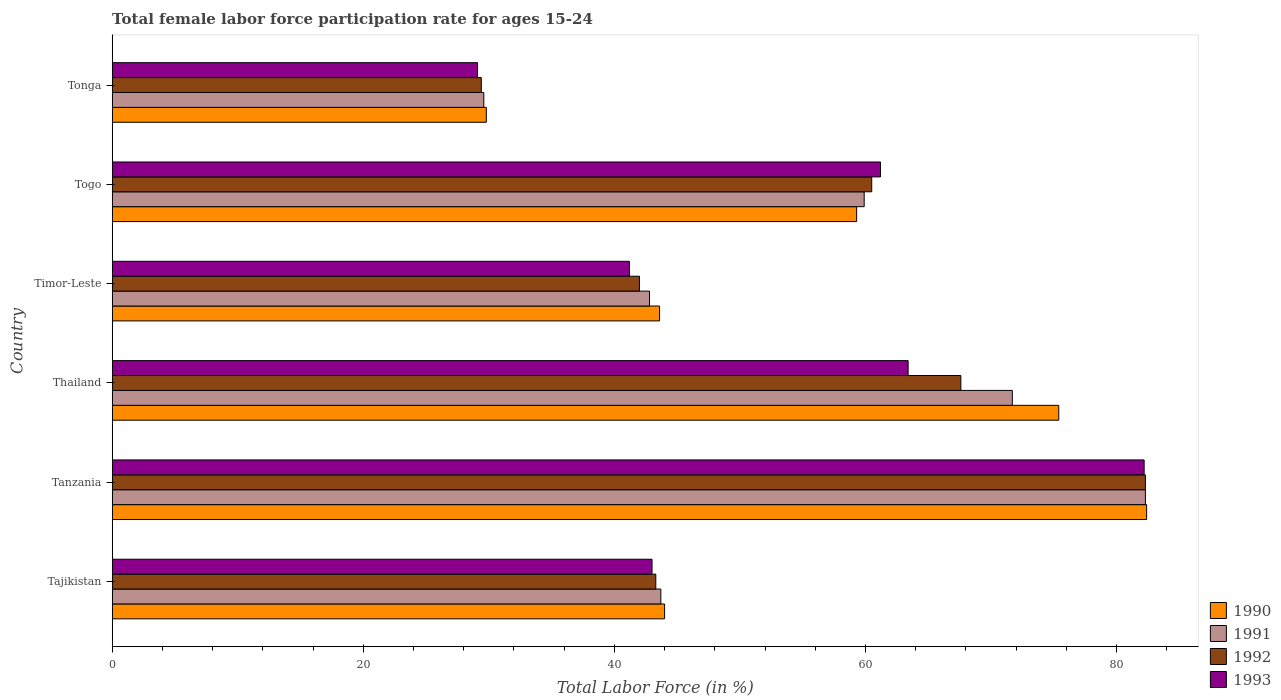How many different coloured bars are there?
Your answer should be compact. 4. How many groups of bars are there?
Provide a succinct answer. 6. Are the number of bars per tick equal to the number of legend labels?
Provide a succinct answer. Yes. Are the number of bars on each tick of the Y-axis equal?
Give a very brief answer. Yes. What is the label of the 3rd group of bars from the top?
Ensure brevity in your answer.  Timor-Leste. In how many cases, is the number of bars for a given country not equal to the number of legend labels?
Your response must be concise. 0. What is the female labor force participation rate in 1991 in Togo?
Give a very brief answer. 59.9. Across all countries, what is the maximum female labor force participation rate in 1991?
Your response must be concise. 82.3. Across all countries, what is the minimum female labor force participation rate in 1993?
Offer a terse response. 29.1. In which country was the female labor force participation rate in 1991 maximum?
Provide a succinct answer. Tanzania. In which country was the female labor force participation rate in 1990 minimum?
Your answer should be compact. Tonga. What is the total female labor force participation rate in 1993 in the graph?
Your answer should be very brief. 320.1. What is the difference between the female labor force participation rate in 1993 in Tajikistan and that in Timor-Leste?
Your answer should be compact. 1.8. What is the difference between the female labor force participation rate in 1990 in Togo and the female labor force participation rate in 1991 in Tanzania?
Your answer should be compact. -23. What is the average female labor force participation rate in 1991 per country?
Keep it short and to the point. 55. What is the difference between the female labor force participation rate in 1992 and female labor force participation rate in 1991 in Togo?
Your answer should be compact. 0.6. In how many countries, is the female labor force participation rate in 1991 greater than 36 %?
Give a very brief answer. 5. What is the ratio of the female labor force participation rate in 1991 in Tanzania to that in Timor-Leste?
Your answer should be very brief. 1.92. Is the difference between the female labor force participation rate in 1992 in Timor-Leste and Tonga greater than the difference between the female labor force participation rate in 1991 in Timor-Leste and Tonga?
Offer a very short reply. No. What is the difference between the highest and the second highest female labor force participation rate in 1991?
Your answer should be very brief. 10.6. What is the difference between the highest and the lowest female labor force participation rate in 1991?
Give a very brief answer. 52.7. What does the 3rd bar from the top in Timor-Leste represents?
Offer a terse response. 1991. Are all the bars in the graph horizontal?
Offer a very short reply. Yes. Are the values on the major ticks of X-axis written in scientific E-notation?
Give a very brief answer. No. Does the graph contain any zero values?
Give a very brief answer. No. What is the title of the graph?
Offer a very short reply. Total female labor force participation rate for ages 15-24. What is the Total Labor Force (in %) in 1991 in Tajikistan?
Provide a short and direct response. 43.7. What is the Total Labor Force (in %) in 1992 in Tajikistan?
Provide a short and direct response. 43.3. What is the Total Labor Force (in %) of 1990 in Tanzania?
Offer a very short reply. 82.4. What is the Total Labor Force (in %) in 1991 in Tanzania?
Make the answer very short. 82.3. What is the Total Labor Force (in %) in 1992 in Tanzania?
Provide a succinct answer. 82.3. What is the Total Labor Force (in %) of 1993 in Tanzania?
Ensure brevity in your answer.  82.2. What is the Total Labor Force (in %) of 1990 in Thailand?
Provide a short and direct response. 75.4. What is the Total Labor Force (in %) in 1991 in Thailand?
Provide a short and direct response. 71.7. What is the Total Labor Force (in %) of 1992 in Thailand?
Provide a succinct answer. 67.6. What is the Total Labor Force (in %) in 1993 in Thailand?
Provide a succinct answer. 63.4. What is the Total Labor Force (in %) of 1990 in Timor-Leste?
Make the answer very short. 43.6. What is the Total Labor Force (in %) of 1991 in Timor-Leste?
Provide a short and direct response. 42.8. What is the Total Labor Force (in %) of 1993 in Timor-Leste?
Ensure brevity in your answer.  41.2. What is the Total Labor Force (in %) of 1990 in Togo?
Provide a succinct answer. 59.3. What is the Total Labor Force (in %) of 1991 in Togo?
Your answer should be compact. 59.9. What is the Total Labor Force (in %) in 1992 in Togo?
Offer a very short reply. 60.5. What is the Total Labor Force (in %) in 1993 in Togo?
Your answer should be compact. 61.2. What is the Total Labor Force (in %) of 1990 in Tonga?
Give a very brief answer. 29.8. What is the Total Labor Force (in %) of 1991 in Tonga?
Give a very brief answer. 29.6. What is the Total Labor Force (in %) in 1992 in Tonga?
Offer a very short reply. 29.4. What is the Total Labor Force (in %) in 1993 in Tonga?
Your answer should be very brief. 29.1. Across all countries, what is the maximum Total Labor Force (in %) in 1990?
Give a very brief answer. 82.4. Across all countries, what is the maximum Total Labor Force (in %) of 1991?
Your answer should be very brief. 82.3. Across all countries, what is the maximum Total Labor Force (in %) of 1992?
Your answer should be compact. 82.3. Across all countries, what is the maximum Total Labor Force (in %) of 1993?
Make the answer very short. 82.2. Across all countries, what is the minimum Total Labor Force (in %) in 1990?
Your answer should be compact. 29.8. Across all countries, what is the minimum Total Labor Force (in %) in 1991?
Offer a very short reply. 29.6. Across all countries, what is the minimum Total Labor Force (in %) of 1992?
Your answer should be very brief. 29.4. Across all countries, what is the minimum Total Labor Force (in %) of 1993?
Your answer should be very brief. 29.1. What is the total Total Labor Force (in %) of 1990 in the graph?
Your answer should be very brief. 334.5. What is the total Total Labor Force (in %) of 1991 in the graph?
Provide a short and direct response. 330. What is the total Total Labor Force (in %) in 1992 in the graph?
Your answer should be compact. 325.1. What is the total Total Labor Force (in %) in 1993 in the graph?
Give a very brief answer. 320.1. What is the difference between the Total Labor Force (in %) in 1990 in Tajikistan and that in Tanzania?
Offer a very short reply. -38.4. What is the difference between the Total Labor Force (in %) of 1991 in Tajikistan and that in Tanzania?
Your response must be concise. -38.6. What is the difference between the Total Labor Force (in %) of 1992 in Tajikistan and that in Tanzania?
Give a very brief answer. -39. What is the difference between the Total Labor Force (in %) of 1993 in Tajikistan and that in Tanzania?
Your response must be concise. -39.2. What is the difference between the Total Labor Force (in %) of 1990 in Tajikistan and that in Thailand?
Your response must be concise. -31.4. What is the difference between the Total Labor Force (in %) in 1992 in Tajikistan and that in Thailand?
Give a very brief answer. -24.3. What is the difference between the Total Labor Force (in %) in 1993 in Tajikistan and that in Thailand?
Your answer should be very brief. -20.4. What is the difference between the Total Labor Force (in %) of 1990 in Tajikistan and that in Timor-Leste?
Ensure brevity in your answer.  0.4. What is the difference between the Total Labor Force (in %) in 1991 in Tajikistan and that in Timor-Leste?
Offer a very short reply. 0.9. What is the difference between the Total Labor Force (in %) of 1992 in Tajikistan and that in Timor-Leste?
Provide a short and direct response. 1.3. What is the difference between the Total Labor Force (in %) of 1993 in Tajikistan and that in Timor-Leste?
Your answer should be very brief. 1.8. What is the difference between the Total Labor Force (in %) in 1990 in Tajikistan and that in Togo?
Your response must be concise. -15.3. What is the difference between the Total Labor Force (in %) in 1991 in Tajikistan and that in Togo?
Your answer should be compact. -16.2. What is the difference between the Total Labor Force (in %) in 1992 in Tajikistan and that in Togo?
Your answer should be very brief. -17.2. What is the difference between the Total Labor Force (in %) in 1993 in Tajikistan and that in Togo?
Offer a very short reply. -18.2. What is the difference between the Total Labor Force (in %) of 1990 in Tajikistan and that in Tonga?
Offer a very short reply. 14.2. What is the difference between the Total Labor Force (in %) in 1991 in Tajikistan and that in Tonga?
Give a very brief answer. 14.1. What is the difference between the Total Labor Force (in %) of 1993 in Tajikistan and that in Tonga?
Give a very brief answer. 13.9. What is the difference between the Total Labor Force (in %) in 1991 in Tanzania and that in Thailand?
Offer a terse response. 10.6. What is the difference between the Total Labor Force (in %) in 1992 in Tanzania and that in Thailand?
Give a very brief answer. 14.7. What is the difference between the Total Labor Force (in %) in 1990 in Tanzania and that in Timor-Leste?
Ensure brevity in your answer.  38.8. What is the difference between the Total Labor Force (in %) of 1991 in Tanzania and that in Timor-Leste?
Ensure brevity in your answer.  39.5. What is the difference between the Total Labor Force (in %) in 1992 in Tanzania and that in Timor-Leste?
Your answer should be compact. 40.3. What is the difference between the Total Labor Force (in %) in 1993 in Tanzania and that in Timor-Leste?
Give a very brief answer. 41. What is the difference between the Total Labor Force (in %) in 1990 in Tanzania and that in Togo?
Give a very brief answer. 23.1. What is the difference between the Total Labor Force (in %) of 1991 in Tanzania and that in Togo?
Ensure brevity in your answer.  22.4. What is the difference between the Total Labor Force (in %) of 1992 in Tanzania and that in Togo?
Provide a short and direct response. 21.8. What is the difference between the Total Labor Force (in %) of 1990 in Tanzania and that in Tonga?
Provide a short and direct response. 52.6. What is the difference between the Total Labor Force (in %) of 1991 in Tanzania and that in Tonga?
Your response must be concise. 52.7. What is the difference between the Total Labor Force (in %) in 1992 in Tanzania and that in Tonga?
Give a very brief answer. 52.9. What is the difference between the Total Labor Force (in %) in 1993 in Tanzania and that in Tonga?
Your answer should be compact. 53.1. What is the difference between the Total Labor Force (in %) of 1990 in Thailand and that in Timor-Leste?
Offer a terse response. 31.8. What is the difference between the Total Labor Force (in %) in 1991 in Thailand and that in Timor-Leste?
Provide a succinct answer. 28.9. What is the difference between the Total Labor Force (in %) of 1992 in Thailand and that in Timor-Leste?
Provide a succinct answer. 25.6. What is the difference between the Total Labor Force (in %) of 1990 in Thailand and that in Togo?
Provide a short and direct response. 16.1. What is the difference between the Total Labor Force (in %) of 1992 in Thailand and that in Togo?
Offer a very short reply. 7.1. What is the difference between the Total Labor Force (in %) in 1993 in Thailand and that in Togo?
Keep it short and to the point. 2.2. What is the difference between the Total Labor Force (in %) in 1990 in Thailand and that in Tonga?
Offer a terse response. 45.6. What is the difference between the Total Labor Force (in %) in 1991 in Thailand and that in Tonga?
Your answer should be compact. 42.1. What is the difference between the Total Labor Force (in %) in 1992 in Thailand and that in Tonga?
Give a very brief answer. 38.2. What is the difference between the Total Labor Force (in %) in 1993 in Thailand and that in Tonga?
Keep it short and to the point. 34.3. What is the difference between the Total Labor Force (in %) of 1990 in Timor-Leste and that in Togo?
Offer a very short reply. -15.7. What is the difference between the Total Labor Force (in %) in 1991 in Timor-Leste and that in Togo?
Your answer should be very brief. -17.1. What is the difference between the Total Labor Force (in %) in 1992 in Timor-Leste and that in Togo?
Your answer should be very brief. -18.5. What is the difference between the Total Labor Force (in %) of 1990 in Timor-Leste and that in Tonga?
Offer a very short reply. 13.8. What is the difference between the Total Labor Force (in %) of 1991 in Timor-Leste and that in Tonga?
Your answer should be very brief. 13.2. What is the difference between the Total Labor Force (in %) of 1992 in Timor-Leste and that in Tonga?
Give a very brief answer. 12.6. What is the difference between the Total Labor Force (in %) of 1993 in Timor-Leste and that in Tonga?
Offer a terse response. 12.1. What is the difference between the Total Labor Force (in %) of 1990 in Togo and that in Tonga?
Your response must be concise. 29.5. What is the difference between the Total Labor Force (in %) in 1991 in Togo and that in Tonga?
Your answer should be compact. 30.3. What is the difference between the Total Labor Force (in %) of 1992 in Togo and that in Tonga?
Provide a succinct answer. 31.1. What is the difference between the Total Labor Force (in %) in 1993 in Togo and that in Tonga?
Give a very brief answer. 32.1. What is the difference between the Total Labor Force (in %) of 1990 in Tajikistan and the Total Labor Force (in %) of 1991 in Tanzania?
Your response must be concise. -38.3. What is the difference between the Total Labor Force (in %) of 1990 in Tajikistan and the Total Labor Force (in %) of 1992 in Tanzania?
Provide a succinct answer. -38.3. What is the difference between the Total Labor Force (in %) in 1990 in Tajikistan and the Total Labor Force (in %) in 1993 in Tanzania?
Offer a very short reply. -38.2. What is the difference between the Total Labor Force (in %) of 1991 in Tajikistan and the Total Labor Force (in %) of 1992 in Tanzania?
Your answer should be very brief. -38.6. What is the difference between the Total Labor Force (in %) in 1991 in Tajikistan and the Total Labor Force (in %) in 1993 in Tanzania?
Offer a terse response. -38.5. What is the difference between the Total Labor Force (in %) in 1992 in Tajikistan and the Total Labor Force (in %) in 1993 in Tanzania?
Give a very brief answer. -38.9. What is the difference between the Total Labor Force (in %) in 1990 in Tajikistan and the Total Labor Force (in %) in 1991 in Thailand?
Offer a terse response. -27.7. What is the difference between the Total Labor Force (in %) of 1990 in Tajikistan and the Total Labor Force (in %) of 1992 in Thailand?
Ensure brevity in your answer.  -23.6. What is the difference between the Total Labor Force (in %) in 1990 in Tajikistan and the Total Labor Force (in %) in 1993 in Thailand?
Provide a succinct answer. -19.4. What is the difference between the Total Labor Force (in %) in 1991 in Tajikistan and the Total Labor Force (in %) in 1992 in Thailand?
Your answer should be very brief. -23.9. What is the difference between the Total Labor Force (in %) in 1991 in Tajikistan and the Total Labor Force (in %) in 1993 in Thailand?
Your response must be concise. -19.7. What is the difference between the Total Labor Force (in %) in 1992 in Tajikistan and the Total Labor Force (in %) in 1993 in Thailand?
Provide a succinct answer. -20.1. What is the difference between the Total Labor Force (in %) of 1991 in Tajikistan and the Total Labor Force (in %) of 1993 in Timor-Leste?
Provide a short and direct response. 2.5. What is the difference between the Total Labor Force (in %) in 1992 in Tajikistan and the Total Labor Force (in %) in 1993 in Timor-Leste?
Ensure brevity in your answer.  2.1. What is the difference between the Total Labor Force (in %) in 1990 in Tajikistan and the Total Labor Force (in %) in 1991 in Togo?
Ensure brevity in your answer.  -15.9. What is the difference between the Total Labor Force (in %) in 1990 in Tajikistan and the Total Labor Force (in %) in 1992 in Togo?
Make the answer very short. -16.5. What is the difference between the Total Labor Force (in %) in 1990 in Tajikistan and the Total Labor Force (in %) in 1993 in Togo?
Make the answer very short. -17.2. What is the difference between the Total Labor Force (in %) of 1991 in Tajikistan and the Total Labor Force (in %) of 1992 in Togo?
Offer a very short reply. -16.8. What is the difference between the Total Labor Force (in %) of 1991 in Tajikistan and the Total Labor Force (in %) of 1993 in Togo?
Make the answer very short. -17.5. What is the difference between the Total Labor Force (in %) of 1992 in Tajikistan and the Total Labor Force (in %) of 1993 in Togo?
Offer a terse response. -17.9. What is the difference between the Total Labor Force (in %) of 1990 in Tajikistan and the Total Labor Force (in %) of 1991 in Tonga?
Your answer should be compact. 14.4. What is the difference between the Total Labor Force (in %) in 1990 in Tajikistan and the Total Labor Force (in %) in 1992 in Tonga?
Provide a short and direct response. 14.6. What is the difference between the Total Labor Force (in %) in 1992 in Tajikistan and the Total Labor Force (in %) in 1993 in Tonga?
Provide a succinct answer. 14.2. What is the difference between the Total Labor Force (in %) in 1990 in Tanzania and the Total Labor Force (in %) in 1991 in Thailand?
Your answer should be compact. 10.7. What is the difference between the Total Labor Force (in %) in 1990 in Tanzania and the Total Labor Force (in %) in 1992 in Thailand?
Your response must be concise. 14.8. What is the difference between the Total Labor Force (in %) in 1990 in Tanzania and the Total Labor Force (in %) in 1993 in Thailand?
Ensure brevity in your answer.  19. What is the difference between the Total Labor Force (in %) in 1992 in Tanzania and the Total Labor Force (in %) in 1993 in Thailand?
Make the answer very short. 18.9. What is the difference between the Total Labor Force (in %) of 1990 in Tanzania and the Total Labor Force (in %) of 1991 in Timor-Leste?
Your answer should be compact. 39.6. What is the difference between the Total Labor Force (in %) in 1990 in Tanzania and the Total Labor Force (in %) in 1992 in Timor-Leste?
Give a very brief answer. 40.4. What is the difference between the Total Labor Force (in %) in 1990 in Tanzania and the Total Labor Force (in %) in 1993 in Timor-Leste?
Provide a short and direct response. 41.2. What is the difference between the Total Labor Force (in %) of 1991 in Tanzania and the Total Labor Force (in %) of 1992 in Timor-Leste?
Offer a terse response. 40.3. What is the difference between the Total Labor Force (in %) of 1991 in Tanzania and the Total Labor Force (in %) of 1993 in Timor-Leste?
Provide a short and direct response. 41.1. What is the difference between the Total Labor Force (in %) of 1992 in Tanzania and the Total Labor Force (in %) of 1993 in Timor-Leste?
Offer a terse response. 41.1. What is the difference between the Total Labor Force (in %) of 1990 in Tanzania and the Total Labor Force (in %) of 1991 in Togo?
Ensure brevity in your answer.  22.5. What is the difference between the Total Labor Force (in %) of 1990 in Tanzania and the Total Labor Force (in %) of 1992 in Togo?
Make the answer very short. 21.9. What is the difference between the Total Labor Force (in %) of 1990 in Tanzania and the Total Labor Force (in %) of 1993 in Togo?
Provide a short and direct response. 21.2. What is the difference between the Total Labor Force (in %) in 1991 in Tanzania and the Total Labor Force (in %) in 1992 in Togo?
Provide a succinct answer. 21.8. What is the difference between the Total Labor Force (in %) in 1991 in Tanzania and the Total Labor Force (in %) in 1993 in Togo?
Provide a short and direct response. 21.1. What is the difference between the Total Labor Force (in %) of 1992 in Tanzania and the Total Labor Force (in %) of 1993 in Togo?
Your response must be concise. 21.1. What is the difference between the Total Labor Force (in %) in 1990 in Tanzania and the Total Labor Force (in %) in 1991 in Tonga?
Your response must be concise. 52.8. What is the difference between the Total Labor Force (in %) in 1990 in Tanzania and the Total Labor Force (in %) in 1992 in Tonga?
Provide a succinct answer. 53. What is the difference between the Total Labor Force (in %) in 1990 in Tanzania and the Total Labor Force (in %) in 1993 in Tonga?
Your answer should be very brief. 53.3. What is the difference between the Total Labor Force (in %) in 1991 in Tanzania and the Total Labor Force (in %) in 1992 in Tonga?
Your response must be concise. 52.9. What is the difference between the Total Labor Force (in %) of 1991 in Tanzania and the Total Labor Force (in %) of 1993 in Tonga?
Ensure brevity in your answer.  53.2. What is the difference between the Total Labor Force (in %) in 1992 in Tanzania and the Total Labor Force (in %) in 1993 in Tonga?
Your response must be concise. 53.2. What is the difference between the Total Labor Force (in %) of 1990 in Thailand and the Total Labor Force (in %) of 1991 in Timor-Leste?
Offer a very short reply. 32.6. What is the difference between the Total Labor Force (in %) in 1990 in Thailand and the Total Labor Force (in %) in 1992 in Timor-Leste?
Provide a short and direct response. 33.4. What is the difference between the Total Labor Force (in %) in 1990 in Thailand and the Total Labor Force (in %) in 1993 in Timor-Leste?
Your response must be concise. 34.2. What is the difference between the Total Labor Force (in %) in 1991 in Thailand and the Total Labor Force (in %) in 1992 in Timor-Leste?
Your response must be concise. 29.7. What is the difference between the Total Labor Force (in %) of 1991 in Thailand and the Total Labor Force (in %) of 1993 in Timor-Leste?
Give a very brief answer. 30.5. What is the difference between the Total Labor Force (in %) in 1992 in Thailand and the Total Labor Force (in %) in 1993 in Timor-Leste?
Your answer should be very brief. 26.4. What is the difference between the Total Labor Force (in %) in 1990 in Thailand and the Total Labor Force (in %) in 1991 in Togo?
Your answer should be very brief. 15.5. What is the difference between the Total Labor Force (in %) in 1990 in Thailand and the Total Labor Force (in %) in 1993 in Togo?
Provide a succinct answer. 14.2. What is the difference between the Total Labor Force (in %) in 1991 in Thailand and the Total Labor Force (in %) in 1992 in Togo?
Make the answer very short. 11.2. What is the difference between the Total Labor Force (in %) in 1991 in Thailand and the Total Labor Force (in %) in 1993 in Togo?
Your answer should be compact. 10.5. What is the difference between the Total Labor Force (in %) in 1990 in Thailand and the Total Labor Force (in %) in 1991 in Tonga?
Keep it short and to the point. 45.8. What is the difference between the Total Labor Force (in %) in 1990 in Thailand and the Total Labor Force (in %) in 1992 in Tonga?
Offer a very short reply. 46. What is the difference between the Total Labor Force (in %) of 1990 in Thailand and the Total Labor Force (in %) of 1993 in Tonga?
Your response must be concise. 46.3. What is the difference between the Total Labor Force (in %) in 1991 in Thailand and the Total Labor Force (in %) in 1992 in Tonga?
Your answer should be very brief. 42.3. What is the difference between the Total Labor Force (in %) of 1991 in Thailand and the Total Labor Force (in %) of 1993 in Tonga?
Make the answer very short. 42.6. What is the difference between the Total Labor Force (in %) in 1992 in Thailand and the Total Labor Force (in %) in 1993 in Tonga?
Make the answer very short. 38.5. What is the difference between the Total Labor Force (in %) in 1990 in Timor-Leste and the Total Labor Force (in %) in 1991 in Togo?
Your answer should be very brief. -16.3. What is the difference between the Total Labor Force (in %) in 1990 in Timor-Leste and the Total Labor Force (in %) in 1992 in Togo?
Offer a very short reply. -16.9. What is the difference between the Total Labor Force (in %) in 1990 in Timor-Leste and the Total Labor Force (in %) in 1993 in Togo?
Your response must be concise. -17.6. What is the difference between the Total Labor Force (in %) in 1991 in Timor-Leste and the Total Labor Force (in %) in 1992 in Togo?
Give a very brief answer. -17.7. What is the difference between the Total Labor Force (in %) in 1991 in Timor-Leste and the Total Labor Force (in %) in 1993 in Togo?
Keep it short and to the point. -18.4. What is the difference between the Total Labor Force (in %) in 1992 in Timor-Leste and the Total Labor Force (in %) in 1993 in Togo?
Offer a terse response. -19.2. What is the difference between the Total Labor Force (in %) of 1990 in Timor-Leste and the Total Labor Force (in %) of 1991 in Tonga?
Make the answer very short. 14. What is the difference between the Total Labor Force (in %) of 1990 in Timor-Leste and the Total Labor Force (in %) of 1993 in Tonga?
Your answer should be compact. 14.5. What is the difference between the Total Labor Force (in %) in 1991 in Timor-Leste and the Total Labor Force (in %) in 1992 in Tonga?
Give a very brief answer. 13.4. What is the difference between the Total Labor Force (in %) of 1991 in Timor-Leste and the Total Labor Force (in %) of 1993 in Tonga?
Your response must be concise. 13.7. What is the difference between the Total Labor Force (in %) in 1990 in Togo and the Total Labor Force (in %) in 1991 in Tonga?
Offer a terse response. 29.7. What is the difference between the Total Labor Force (in %) in 1990 in Togo and the Total Labor Force (in %) in 1992 in Tonga?
Your answer should be compact. 29.9. What is the difference between the Total Labor Force (in %) in 1990 in Togo and the Total Labor Force (in %) in 1993 in Tonga?
Ensure brevity in your answer.  30.2. What is the difference between the Total Labor Force (in %) in 1991 in Togo and the Total Labor Force (in %) in 1992 in Tonga?
Keep it short and to the point. 30.5. What is the difference between the Total Labor Force (in %) of 1991 in Togo and the Total Labor Force (in %) of 1993 in Tonga?
Your answer should be very brief. 30.8. What is the difference between the Total Labor Force (in %) of 1992 in Togo and the Total Labor Force (in %) of 1993 in Tonga?
Offer a very short reply. 31.4. What is the average Total Labor Force (in %) of 1990 per country?
Keep it short and to the point. 55.75. What is the average Total Labor Force (in %) in 1992 per country?
Provide a short and direct response. 54.18. What is the average Total Labor Force (in %) in 1993 per country?
Offer a terse response. 53.35. What is the difference between the Total Labor Force (in %) of 1990 and Total Labor Force (in %) of 1992 in Tajikistan?
Provide a succinct answer. 0.7. What is the difference between the Total Labor Force (in %) in 1991 and Total Labor Force (in %) in 1992 in Tajikistan?
Your answer should be compact. 0.4. What is the difference between the Total Labor Force (in %) of 1992 and Total Labor Force (in %) of 1993 in Tajikistan?
Give a very brief answer. 0.3. What is the difference between the Total Labor Force (in %) of 1990 and Total Labor Force (in %) of 1992 in Tanzania?
Give a very brief answer. 0.1. What is the difference between the Total Labor Force (in %) in 1990 and Total Labor Force (in %) in 1993 in Tanzania?
Your response must be concise. 0.2. What is the difference between the Total Labor Force (in %) of 1990 and Total Labor Force (in %) of 1991 in Thailand?
Make the answer very short. 3.7. What is the difference between the Total Labor Force (in %) of 1990 and Total Labor Force (in %) of 1992 in Thailand?
Offer a very short reply. 7.8. What is the difference between the Total Labor Force (in %) in 1990 and Total Labor Force (in %) in 1992 in Timor-Leste?
Your response must be concise. 1.6. What is the difference between the Total Labor Force (in %) in 1991 and Total Labor Force (in %) in 1992 in Timor-Leste?
Give a very brief answer. 0.8. What is the difference between the Total Labor Force (in %) in 1992 and Total Labor Force (in %) in 1993 in Timor-Leste?
Ensure brevity in your answer.  0.8. What is the difference between the Total Labor Force (in %) in 1990 and Total Labor Force (in %) in 1992 in Togo?
Ensure brevity in your answer.  -1.2. What is the difference between the Total Labor Force (in %) of 1991 and Total Labor Force (in %) of 1992 in Togo?
Ensure brevity in your answer.  -0.6. What is the difference between the Total Labor Force (in %) in 1991 and Total Labor Force (in %) in 1993 in Togo?
Keep it short and to the point. -1.3. What is the difference between the Total Labor Force (in %) of 1990 and Total Labor Force (in %) of 1993 in Tonga?
Offer a terse response. 0.7. What is the difference between the Total Labor Force (in %) of 1991 and Total Labor Force (in %) of 1992 in Tonga?
Offer a very short reply. 0.2. What is the difference between the Total Labor Force (in %) in 1991 and Total Labor Force (in %) in 1993 in Tonga?
Offer a terse response. 0.5. What is the ratio of the Total Labor Force (in %) of 1990 in Tajikistan to that in Tanzania?
Keep it short and to the point. 0.53. What is the ratio of the Total Labor Force (in %) in 1991 in Tajikistan to that in Tanzania?
Ensure brevity in your answer.  0.53. What is the ratio of the Total Labor Force (in %) of 1992 in Tajikistan to that in Tanzania?
Give a very brief answer. 0.53. What is the ratio of the Total Labor Force (in %) in 1993 in Tajikistan to that in Tanzania?
Provide a succinct answer. 0.52. What is the ratio of the Total Labor Force (in %) in 1990 in Tajikistan to that in Thailand?
Provide a short and direct response. 0.58. What is the ratio of the Total Labor Force (in %) of 1991 in Tajikistan to that in Thailand?
Your answer should be compact. 0.61. What is the ratio of the Total Labor Force (in %) in 1992 in Tajikistan to that in Thailand?
Offer a terse response. 0.64. What is the ratio of the Total Labor Force (in %) in 1993 in Tajikistan to that in Thailand?
Keep it short and to the point. 0.68. What is the ratio of the Total Labor Force (in %) in 1990 in Tajikistan to that in Timor-Leste?
Provide a succinct answer. 1.01. What is the ratio of the Total Labor Force (in %) in 1991 in Tajikistan to that in Timor-Leste?
Your answer should be very brief. 1.02. What is the ratio of the Total Labor Force (in %) of 1992 in Tajikistan to that in Timor-Leste?
Provide a succinct answer. 1.03. What is the ratio of the Total Labor Force (in %) of 1993 in Tajikistan to that in Timor-Leste?
Ensure brevity in your answer.  1.04. What is the ratio of the Total Labor Force (in %) of 1990 in Tajikistan to that in Togo?
Provide a short and direct response. 0.74. What is the ratio of the Total Labor Force (in %) in 1991 in Tajikistan to that in Togo?
Provide a short and direct response. 0.73. What is the ratio of the Total Labor Force (in %) of 1992 in Tajikistan to that in Togo?
Offer a terse response. 0.72. What is the ratio of the Total Labor Force (in %) of 1993 in Tajikistan to that in Togo?
Your answer should be very brief. 0.7. What is the ratio of the Total Labor Force (in %) in 1990 in Tajikistan to that in Tonga?
Provide a short and direct response. 1.48. What is the ratio of the Total Labor Force (in %) of 1991 in Tajikistan to that in Tonga?
Offer a terse response. 1.48. What is the ratio of the Total Labor Force (in %) in 1992 in Tajikistan to that in Tonga?
Ensure brevity in your answer.  1.47. What is the ratio of the Total Labor Force (in %) of 1993 in Tajikistan to that in Tonga?
Provide a succinct answer. 1.48. What is the ratio of the Total Labor Force (in %) in 1990 in Tanzania to that in Thailand?
Ensure brevity in your answer.  1.09. What is the ratio of the Total Labor Force (in %) in 1991 in Tanzania to that in Thailand?
Your response must be concise. 1.15. What is the ratio of the Total Labor Force (in %) of 1992 in Tanzania to that in Thailand?
Your response must be concise. 1.22. What is the ratio of the Total Labor Force (in %) of 1993 in Tanzania to that in Thailand?
Your response must be concise. 1.3. What is the ratio of the Total Labor Force (in %) in 1990 in Tanzania to that in Timor-Leste?
Keep it short and to the point. 1.89. What is the ratio of the Total Labor Force (in %) of 1991 in Tanzania to that in Timor-Leste?
Keep it short and to the point. 1.92. What is the ratio of the Total Labor Force (in %) in 1992 in Tanzania to that in Timor-Leste?
Your answer should be compact. 1.96. What is the ratio of the Total Labor Force (in %) of 1993 in Tanzania to that in Timor-Leste?
Your response must be concise. 2. What is the ratio of the Total Labor Force (in %) in 1990 in Tanzania to that in Togo?
Your response must be concise. 1.39. What is the ratio of the Total Labor Force (in %) of 1991 in Tanzania to that in Togo?
Your answer should be compact. 1.37. What is the ratio of the Total Labor Force (in %) of 1992 in Tanzania to that in Togo?
Give a very brief answer. 1.36. What is the ratio of the Total Labor Force (in %) of 1993 in Tanzania to that in Togo?
Your response must be concise. 1.34. What is the ratio of the Total Labor Force (in %) in 1990 in Tanzania to that in Tonga?
Offer a very short reply. 2.77. What is the ratio of the Total Labor Force (in %) in 1991 in Tanzania to that in Tonga?
Provide a short and direct response. 2.78. What is the ratio of the Total Labor Force (in %) in 1992 in Tanzania to that in Tonga?
Your answer should be very brief. 2.8. What is the ratio of the Total Labor Force (in %) of 1993 in Tanzania to that in Tonga?
Offer a very short reply. 2.82. What is the ratio of the Total Labor Force (in %) in 1990 in Thailand to that in Timor-Leste?
Keep it short and to the point. 1.73. What is the ratio of the Total Labor Force (in %) in 1991 in Thailand to that in Timor-Leste?
Your response must be concise. 1.68. What is the ratio of the Total Labor Force (in %) of 1992 in Thailand to that in Timor-Leste?
Provide a short and direct response. 1.61. What is the ratio of the Total Labor Force (in %) in 1993 in Thailand to that in Timor-Leste?
Offer a terse response. 1.54. What is the ratio of the Total Labor Force (in %) in 1990 in Thailand to that in Togo?
Provide a short and direct response. 1.27. What is the ratio of the Total Labor Force (in %) in 1991 in Thailand to that in Togo?
Provide a short and direct response. 1.2. What is the ratio of the Total Labor Force (in %) in 1992 in Thailand to that in Togo?
Your answer should be very brief. 1.12. What is the ratio of the Total Labor Force (in %) in 1993 in Thailand to that in Togo?
Provide a succinct answer. 1.04. What is the ratio of the Total Labor Force (in %) of 1990 in Thailand to that in Tonga?
Make the answer very short. 2.53. What is the ratio of the Total Labor Force (in %) of 1991 in Thailand to that in Tonga?
Make the answer very short. 2.42. What is the ratio of the Total Labor Force (in %) of 1992 in Thailand to that in Tonga?
Keep it short and to the point. 2.3. What is the ratio of the Total Labor Force (in %) of 1993 in Thailand to that in Tonga?
Provide a short and direct response. 2.18. What is the ratio of the Total Labor Force (in %) of 1990 in Timor-Leste to that in Togo?
Offer a very short reply. 0.74. What is the ratio of the Total Labor Force (in %) of 1991 in Timor-Leste to that in Togo?
Your answer should be very brief. 0.71. What is the ratio of the Total Labor Force (in %) in 1992 in Timor-Leste to that in Togo?
Your answer should be compact. 0.69. What is the ratio of the Total Labor Force (in %) in 1993 in Timor-Leste to that in Togo?
Ensure brevity in your answer.  0.67. What is the ratio of the Total Labor Force (in %) in 1990 in Timor-Leste to that in Tonga?
Your answer should be compact. 1.46. What is the ratio of the Total Labor Force (in %) in 1991 in Timor-Leste to that in Tonga?
Offer a terse response. 1.45. What is the ratio of the Total Labor Force (in %) in 1992 in Timor-Leste to that in Tonga?
Offer a terse response. 1.43. What is the ratio of the Total Labor Force (in %) in 1993 in Timor-Leste to that in Tonga?
Keep it short and to the point. 1.42. What is the ratio of the Total Labor Force (in %) of 1990 in Togo to that in Tonga?
Offer a very short reply. 1.99. What is the ratio of the Total Labor Force (in %) in 1991 in Togo to that in Tonga?
Provide a short and direct response. 2.02. What is the ratio of the Total Labor Force (in %) of 1992 in Togo to that in Tonga?
Your answer should be very brief. 2.06. What is the ratio of the Total Labor Force (in %) in 1993 in Togo to that in Tonga?
Offer a terse response. 2.1. What is the difference between the highest and the second highest Total Labor Force (in %) of 1992?
Ensure brevity in your answer.  14.7. What is the difference between the highest and the second highest Total Labor Force (in %) in 1993?
Provide a short and direct response. 18.8. What is the difference between the highest and the lowest Total Labor Force (in %) in 1990?
Ensure brevity in your answer.  52.6. What is the difference between the highest and the lowest Total Labor Force (in %) of 1991?
Your answer should be very brief. 52.7. What is the difference between the highest and the lowest Total Labor Force (in %) of 1992?
Your response must be concise. 52.9. What is the difference between the highest and the lowest Total Labor Force (in %) of 1993?
Offer a terse response. 53.1. 